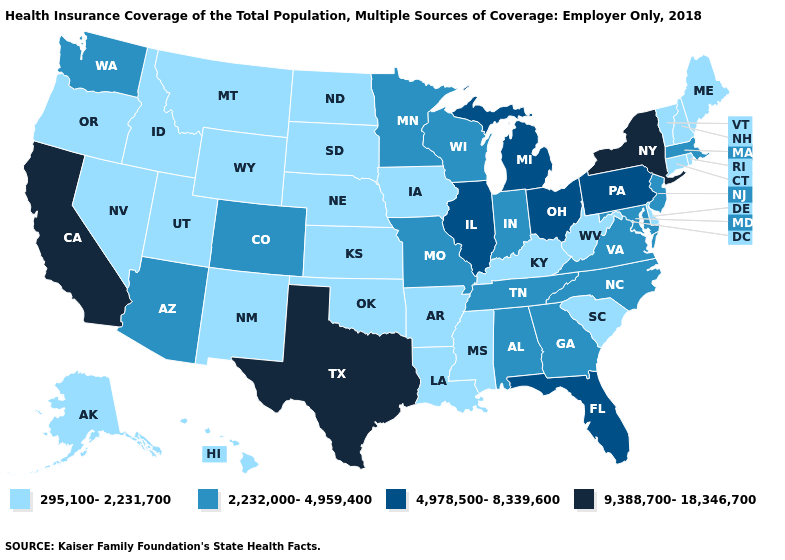Name the states that have a value in the range 4,978,500-8,339,600?
Keep it brief. Florida, Illinois, Michigan, Ohio, Pennsylvania. What is the highest value in the USA?
Short answer required. 9,388,700-18,346,700. Name the states that have a value in the range 9,388,700-18,346,700?
Short answer required. California, New York, Texas. Which states have the highest value in the USA?
Short answer required. California, New York, Texas. Among the states that border Alabama , does Florida have the highest value?
Quick response, please. Yes. Name the states that have a value in the range 9,388,700-18,346,700?
Short answer required. California, New York, Texas. What is the highest value in states that border Kentucky?
Concise answer only. 4,978,500-8,339,600. What is the value of Maine?
Give a very brief answer. 295,100-2,231,700. What is the value of Connecticut?
Keep it brief. 295,100-2,231,700. Name the states that have a value in the range 4,978,500-8,339,600?
Answer briefly. Florida, Illinois, Michigan, Ohio, Pennsylvania. Which states have the highest value in the USA?
Quick response, please. California, New York, Texas. Does Illinois have a higher value than Pennsylvania?
Give a very brief answer. No. What is the value of South Dakota?
Give a very brief answer. 295,100-2,231,700. What is the value of North Dakota?
Answer briefly. 295,100-2,231,700. 